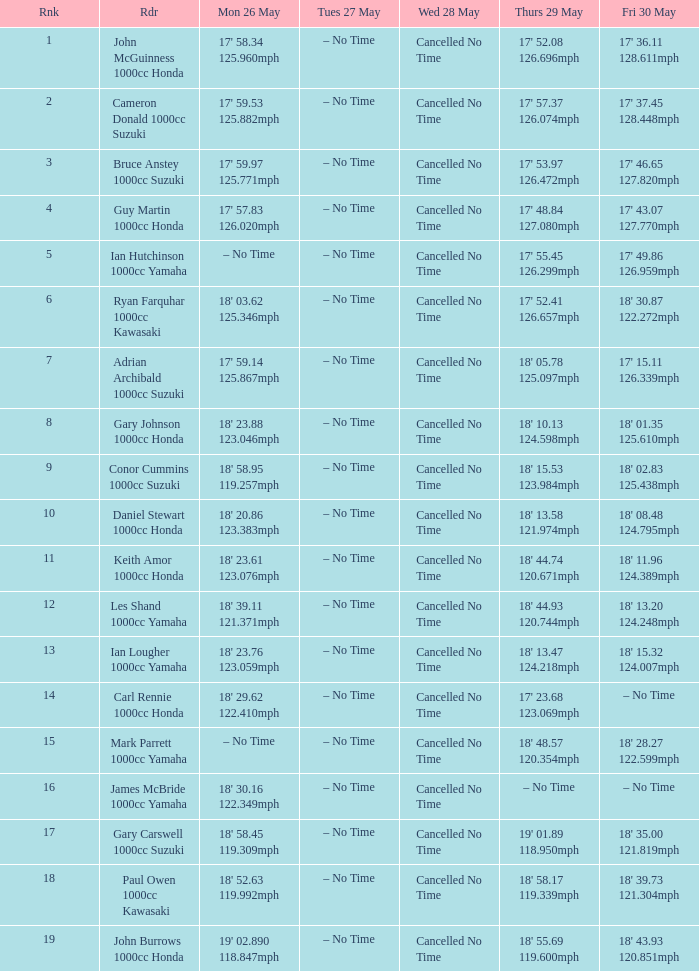960 mph? Cancelled No Time. 